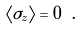Convert formula to latex. <formula><loc_0><loc_0><loc_500><loc_500>\langle \sigma _ { z } \rangle = 0 \ .</formula> 